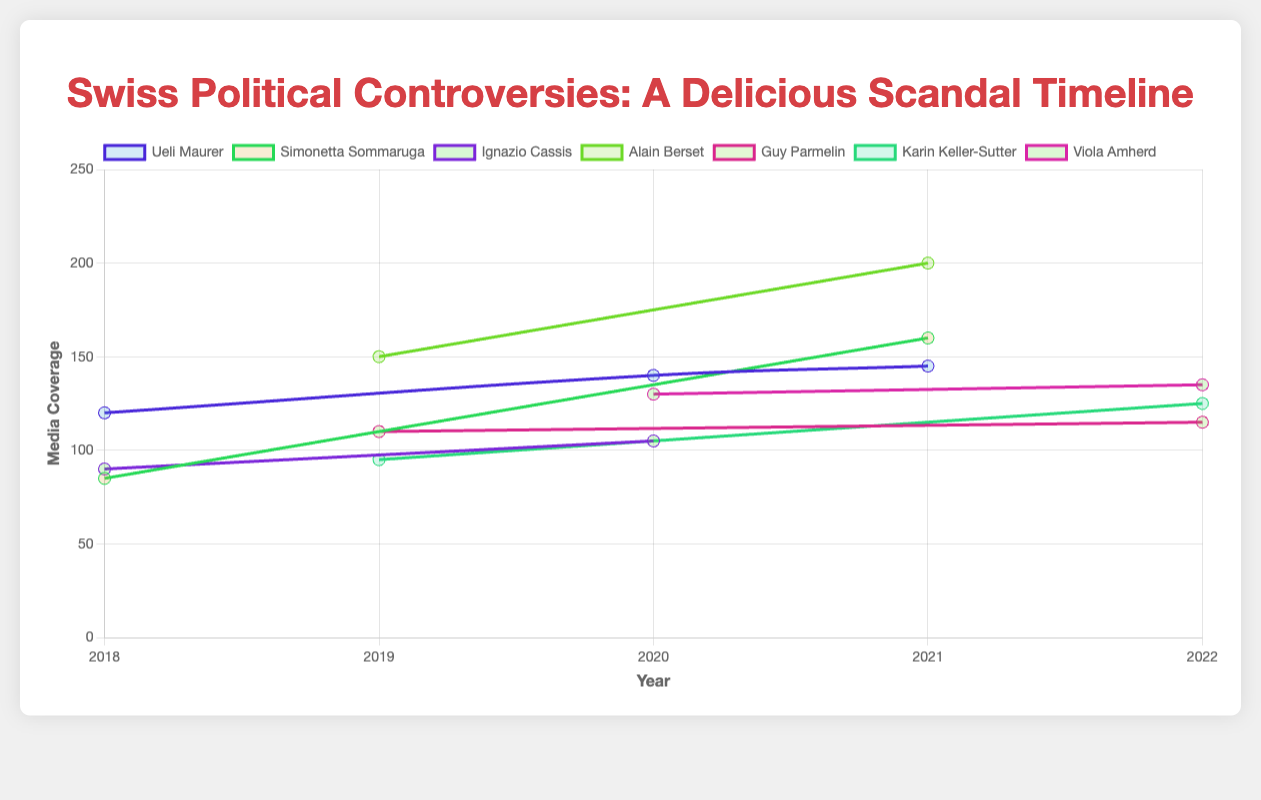1. Which politician had the highest media coverage in 2021? To find the answer, look at the lines representing 2021 and identify the one with the highest point. Alain Berset had a media coverage of 200, which is the highest in that year.
Answer: Alain Berset 2. What is the average media coverage of Ueli Maurer from 2018 to 2021? The media coverage values for Ueli Maurer from 2018 to 2021 are 120 (2018), 140 (2020), and 145 (2021). To find the average: (120 + 140 + 145) / 3 = 405 / 3 = 135.
Answer: 135 3. Did Karin Keller-Sutter's media coverage increase or decrease from 2019 to 2022? Check the points for Karin Keller-Sutter in 2019 and 2022. The media coverage in 2019 was 95, and in 2022 it was 125. Since 125 is greater than 95, the media coverage increased.
Answer: Increase 4. What was the total media coverage of all politicians in 2020? Add up the media coverages of all politicians in 2020: Ueli Maurer (140), Viola Amherd (130), and Ignazio Cassis (105). Total = 140 + 130 + 105 = 375.
Answer: 375 5. Who had more media coverage in 2019, Alain Berset or Guy Parmelin? Compare the media coverage for Alain Berset (150) and Guy Parmelin (110) in 2019. Alain Berset had more media coverage.
Answer: Alain Berset 6. Which politician had the steepest increase in media coverage between 2020 and 2021? Compare the changes in media coverage for all politicians from 2020 to 2021. The changes are:
   - Ueli Maurer: 145 (2021) - 140 (2020) = +5 
   - Simonetta Sommaruga: 160 (2021) - 0 (2020) = +160
   - Alain Berset: 200 (2021) - 0 (2020) = +200
   Note: Simonetta Sommaruga had a controversy and media coverage point in 2021, but none in 2020, suggesting a possible absence of a measured event.
   Alain Berset had the steepest increase.
Answer: Alain Berset 7. Was there any year where Ignazio Cassis had higher media coverage than Simonetta Sommaruga? Compare the media coverages of Ignazio Cassis and Simonetta Sommaruga for the years they both have data points. In 2018: Ignazio Cassis (90) vs. Simonetta Sommaruga (85). Ignazio Cassis had higher coverage.
Answer: Yes, in 2018 8. How did media coverage of Simonetta Sommaruga change from 2018 to 2021? For Simonetta Sommaruga, her media coverage was 85 in 2018 and increased to 160 in 2021.
Answer: Increased 9. Which politician had controversies mentioned in all the years from 2018 to 2021? Check for any politician with data points in all years from 2018 to 2021. Ueli Maurer had controversies in 2018, 2020, and 2021 for continuous mention throughout the years.
Answer: Ueli Maurer 10. Over the years, which controversy had the highest single-year media coverage? Identify the highest media coverage point on the graph. Alain Berset's "Pandemic mismanagement" in 2021 had the highest with 200.
Answer: Pandemic mismanagement (Alain Berset, 2021) 